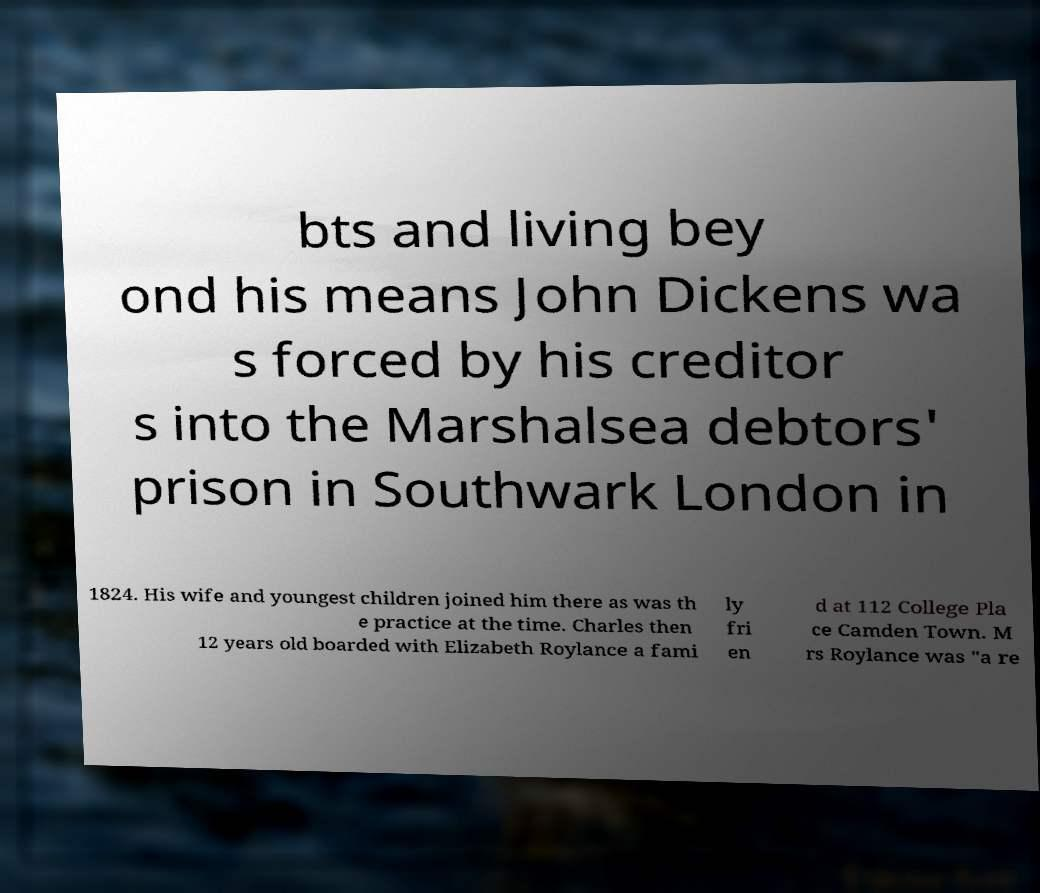For documentation purposes, I need the text within this image transcribed. Could you provide that? bts and living bey ond his means John Dickens wa s forced by his creditor s into the Marshalsea debtors' prison in Southwark London in 1824. His wife and youngest children joined him there as was th e practice at the time. Charles then 12 years old boarded with Elizabeth Roylance a fami ly fri en d at 112 College Pla ce Camden Town. M rs Roylance was "a re 